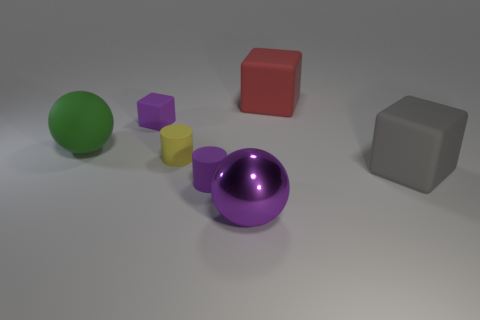There is a big matte object that is both to the left of the gray matte object and in front of the purple block; what color is it?
Keep it short and to the point. Green. What is the shape of the metallic object that is the same color as the small block?
Offer a very short reply. Sphere. What size is the purple thing that is behind the large thing that is to the right of the red cube?
Provide a succinct answer. Small. How many spheres are either large yellow metallic things or big things?
Provide a short and direct response. 2. There is a matte sphere that is the same size as the gray cube; what is its color?
Offer a terse response. Green. What is the shape of the tiny rubber object that is on the right side of the cylinder on the left side of the tiny purple cylinder?
Make the answer very short. Cylinder. Do the purple matte thing that is on the left side of the yellow cylinder and the big gray block have the same size?
Give a very brief answer. No. How many other objects are there of the same material as the small yellow thing?
Provide a short and direct response. 5. How many green objects are either big matte cubes or big matte balls?
Your answer should be very brief. 1. What size is the matte block that is the same color as the large metallic object?
Your response must be concise. Small. 